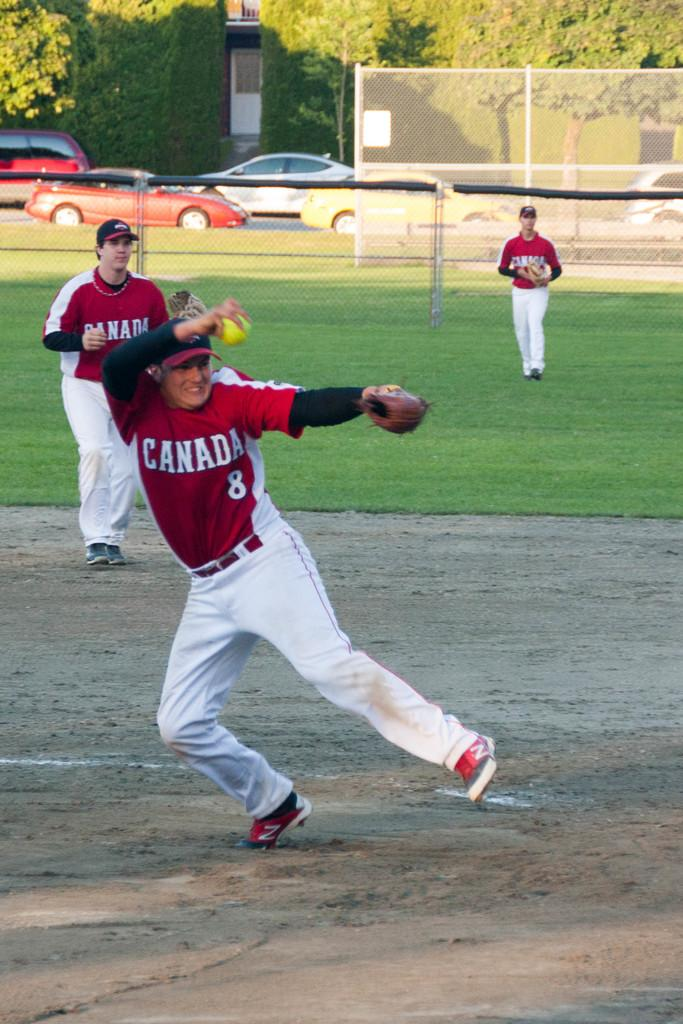<image>
Render a clear and concise summary of the photo. a few men, one which has the word Canada on their shirt 